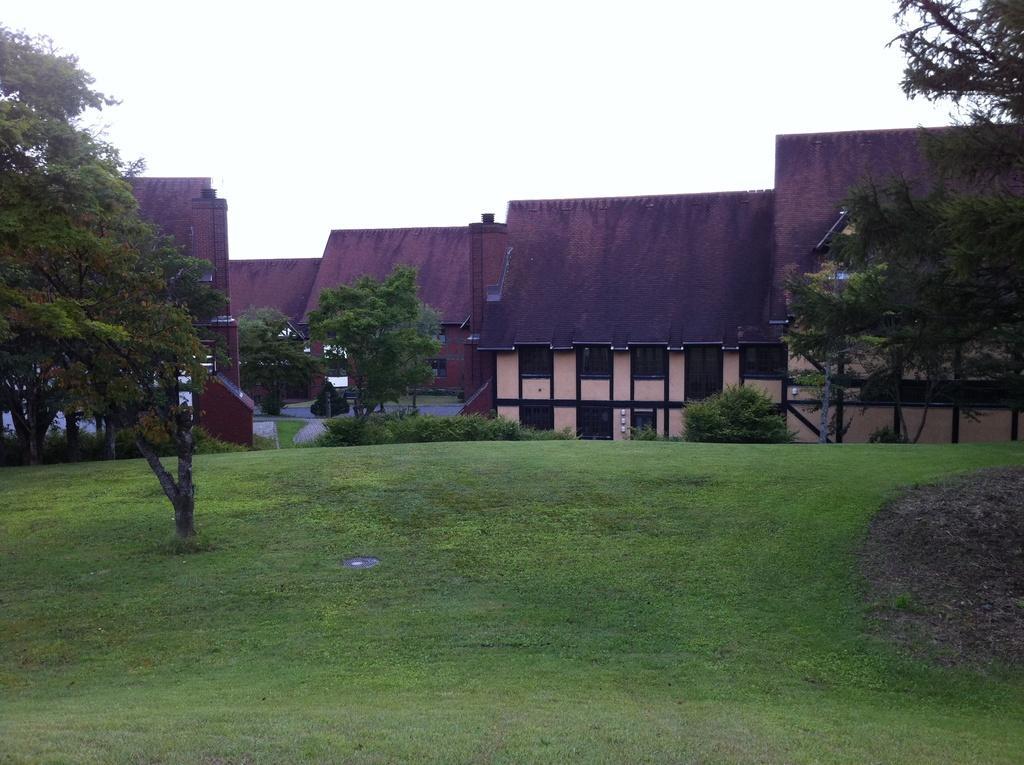In one or two sentences, can you explain what this image depicts? In the image we can see there are many buildings and a road. These are the windows of the building, grass, trees and a white sky. 